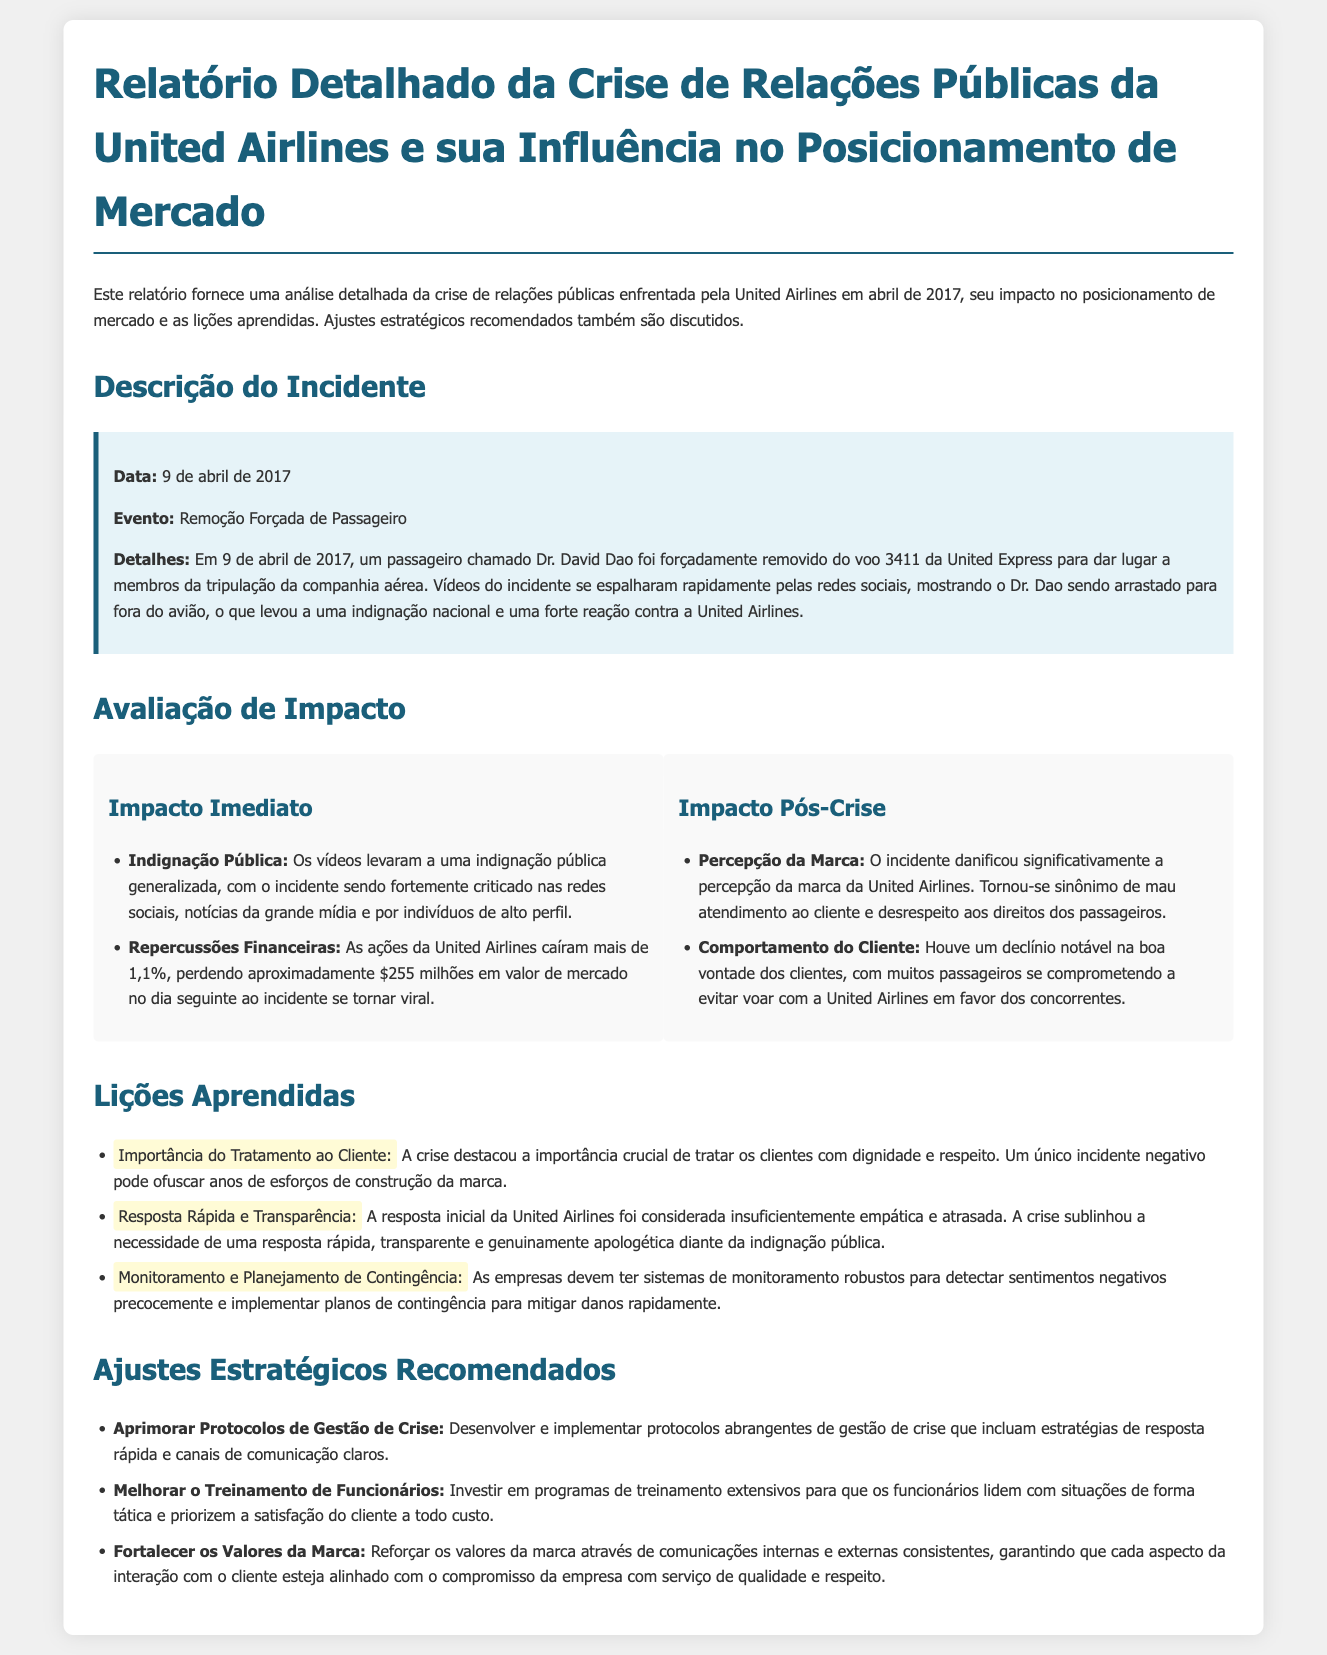qual foi a data do incidente? A data do incidente é fornecida na seção de descrição do incidente, que menciona "9 de abril de 2017".
Answer: 9 de abril de 2017 quem foi o passageiro removido? O documento menciona o nome do passageiro removido como "Dr. David Dao".
Answer: Dr. David Dao qual foi a reação pública inicial ao incidente? O impacto imediato inclui "indignação pública", conforme descrito na seção de avaliação de impacto.
Answer: Indignação pública qual foi o impacto financeiro no dia seguinte ao incidente? O documento relata que as ações da United Airlines caíram mais de 1,1%, resultando em uma perda de "aproximadamente $255 milhões".
Answer: aproximadamente $255 milhões quais são as duas primeiras lições aprendidas? As lições aprendidas incluem "Importância do Tratamento ao Cliente" e "Resposta Rápida e Transparência", que estão listadas na seção de lições aprendidas.
Answer: Importância do Tratamento ao Cliente; Resposta Rápida e Transparência que ajuste estratégico envolve o atendimento ao cliente? O ajuste estratégico mencionado é "Melhorar o Treinamento de Funcionários", que é necessário para priorizar a satisfação do cliente.
Answer: Melhorar o Treinamento de Funcionários qual foi a abordagem inicial da United Airlines à crise? O documento indica que a "resposta inicial" da United Airlines foi considerada "insuficientemente empática e atrasada".
Answer: insuficientemente empática e atrasada como as ações da United Airlines reagiram após o incidente? A avaliação de impacto menciona que as ações da United Airlines "caíram mais de 1,1%".
Answer: caíram mais de 1,1% 